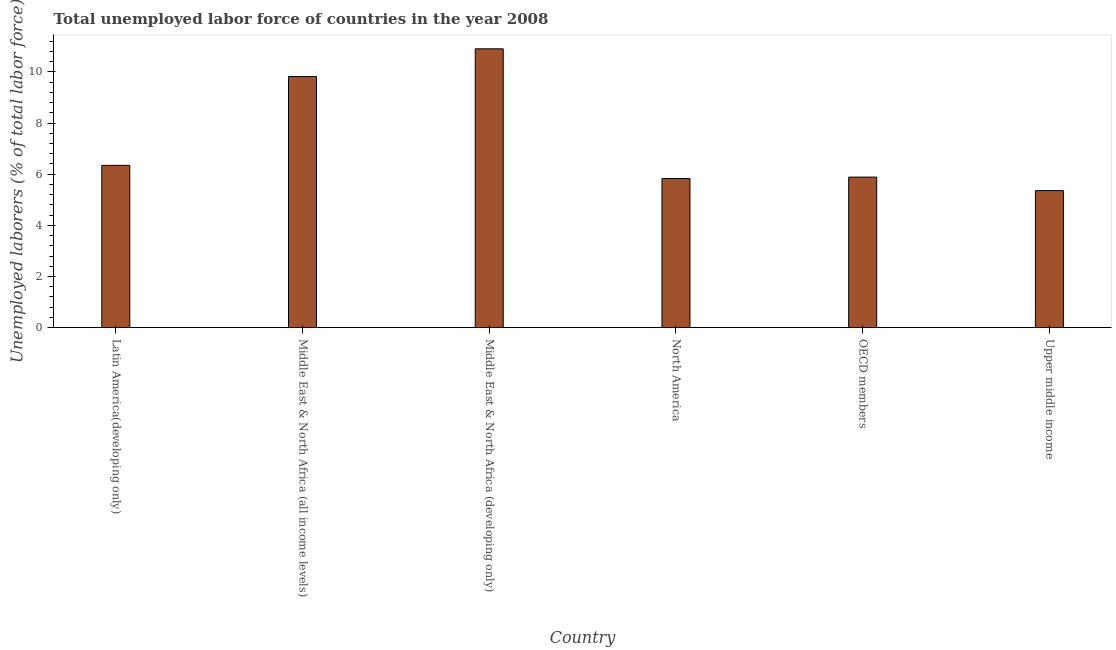Does the graph contain any zero values?
Your answer should be compact. No. Does the graph contain grids?
Provide a succinct answer. No. What is the title of the graph?
Provide a succinct answer. Total unemployed labor force of countries in the year 2008. What is the label or title of the Y-axis?
Offer a very short reply. Unemployed laborers (% of total labor force). What is the total unemployed labour force in Upper middle income?
Make the answer very short. 5.36. Across all countries, what is the maximum total unemployed labour force?
Provide a short and direct response. 10.9. Across all countries, what is the minimum total unemployed labour force?
Offer a terse response. 5.36. In which country was the total unemployed labour force maximum?
Give a very brief answer. Middle East & North Africa (developing only). In which country was the total unemployed labour force minimum?
Your answer should be very brief. Upper middle income. What is the sum of the total unemployed labour force?
Make the answer very short. 44.14. What is the difference between the total unemployed labour force in Middle East & North Africa (all income levels) and Middle East & North Africa (developing only)?
Your response must be concise. -1.08. What is the average total unemployed labour force per country?
Provide a succinct answer. 7.36. What is the median total unemployed labour force?
Ensure brevity in your answer.  6.12. In how many countries, is the total unemployed labour force greater than 2.8 %?
Ensure brevity in your answer.  6. What is the ratio of the total unemployed labour force in Latin America(developing only) to that in North America?
Provide a short and direct response. 1.09. What is the difference between the highest and the second highest total unemployed labour force?
Make the answer very short. 1.08. Is the sum of the total unemployed labour force in Middle East & North Africa (all income levels) and North America greater than the maximum total unemployed labour force across all countries?
Provide a short and direct response. Yes. What is the difference between the highest and the lowest total unemployed labour force?
Give a very brief answer. 5.54. How many bars are there?
Provide a short and direct response. 6. How many countries are there in the graph?
Your answer should be compact. 6. What is the Unemployed laborers (% of total labor force) in Latin America(developing only)?
Give a very brief answer. 6.35. What is the Unemployed laborers (% of total labor force) in Middle East & North Africa (all income levels)?
Give a very brief answer. 9.82. What is the Unemployed laborers (% of total labor force) of Middle East & North Africa (developing only)?
Keep it short and to the point. 10.9. What is the Unemployed laborers (% of total labor force) in North America?
Your answer should be very brief. 5.83. What is the Unemployed laborers (% of total labor force) of OECD members?
Ensure brevity in your answer.  5.89. What is the Unemployed laborers (% of total labor force) in Upper middle income?
Your answer should be very brief. 5.36. What is the difference between the Unemployed laborers (% of total labor force) in Latin America(developing only) and Middle East & North Africa (all income levels)?
Ensure brevity in your answer.  -3.47. What is the difference between the Unemployed laborers (% of total labor force) in Latin America(developing only) and Middle East & North Africa (developing only)?
Provide a succinct answer. -4.56. What is the difference between the Unemployed laborers (% of total labor force) in Latin America(developing only) and North America?
Your answer should be very brief. 0.51. What is the difference between the Unemployed laborers (% of total labor force) in Latin America(developing only) and OECD members?
Make the answer very short. 0.46. What is the difference between the Unemployed laborers (% of total labor force) in Latin America(developing only) and Upper middle income?
Provide a short and direct response. 0.99. What is the difference between the Unemployed laborers (% of total labor force) in Middle East & North Africa (all income levels) and Middle East & North Africa (developing only)?
Keep it short and to the point. -1.08. What is the difference between the Unemployed laborers (% of total labor force) in Middle East & North Africa (all income levels) and North America?
Offer a very short reply. 3.99. What is the difference between the Unemployed laborers (% of total labor force) in Middle East & North Africa (all income levels) and OECD members?
Offer a terse response. 3.93. What is the difference between the Unemployed laborers (% of total labor force) in Middle East & North Africa (all income levels) and Upper middle income?
Your answer should be compact. 4.46. What is the difference between the Unemployed laborers (% of total labor force) in Middle East & North Africa (developing only) and North America?
Offer a very short reply. 5.07. What is the difference between the Unemployed laborers (% of total labor force) in Middle East & North Africa (developing only) and OECD members?
Your answer should be compact. 5.02. What is the difference between the Unemployed laborers (% of total labor force) in Middle East & North Africa (developing only) and Upper middle income?
Your answer should be very brief. 5.54. What is the difference between the Unemployed laborers (% of total labor force) in North America and OECD members?
Make the answer very short. -0.06. What is the difference between the Unemployed laborers (% of total labor force) in North America and Upper middle income?
Offer a terse response. 0.47. What is the difference between the Unemployed laborers (% of total labor force) in OECD members and Upper middle income?
Your response must be concise. 0.53. What is the ratio of the Unemployed laborers (% of total labor force) in Latin America(developing only) to that in Middle East & North Africa (all income levels)?
Make the answer very short. 0.65. What is the ratio of the Unemployed laborers (% of total labor force) in Latin America(developing only) to that in Middle East & North Africa (developing only)?
Make the answer very short. 0.58. What is the ratio of the Unemployed laborers (% of total labor force) in Latin America(developing only) to that in North America?
Your answer should be very brief. 1.09. What is the ratio of the Unemployed laborers (% of total labor force) in Latin America(developing only) to that in OECD members?
Keep it short and to the point. 1.08. What is the ratio of the Unemployed laborers (% of total labor force) in Latin America(developing only) to that in Upper middle income?
Provide a short and direct response. 1.18. What is the ratio of the Unemployed laborers (% of total labor force) in Middle East & North Africa (all income levels) to that in Middle East & North Africa (developing only)?
Provide a short and direct response. 0.9. What is the ratio of the Unemployed laborers (% of total labor force) in Middle East & North Africa (all income levels) to that in North America?
Give a very brief answer. 1.68. What is the ratio of the Unemployed laborers (% of total labor force) in Middle East & North Africa (all income levels) to that in OECD members?
Provide a short and direct response. 1.67. What is the ratio of the Unemployed laborers (% of total labor force) in Middle East & North Africa (all income levels) to that in Upper middle income?
Your answer should be very brief. 1.83. What is the ratio of the Unemployed laborers (% of total labor force) in Middle East & North Africa (developing only) to that in North America?
Make the answer very short. 1.87. What is the ratio of the Unemployed laborers (% of total labor force) in Middle East & North Africa (developing only) to that in OECD members?
Offer a very short reply. 1.85. What is the ratio of the Unemployed laborers (% of total labor force) in Middle East & North Africa (developing only) to that in Upper middle income?
Your answer should be compact. 2.04. What is the ratio of the Unemployed laborers (% of total labor force) in North America to that in Upper middle income?
Keep it short and to the point. 1.09. What is the ratio of the Unemployed laborers (% of total labor force) in OECD members to that in Upper middle income?
Your answer should be compact. 1.1. 